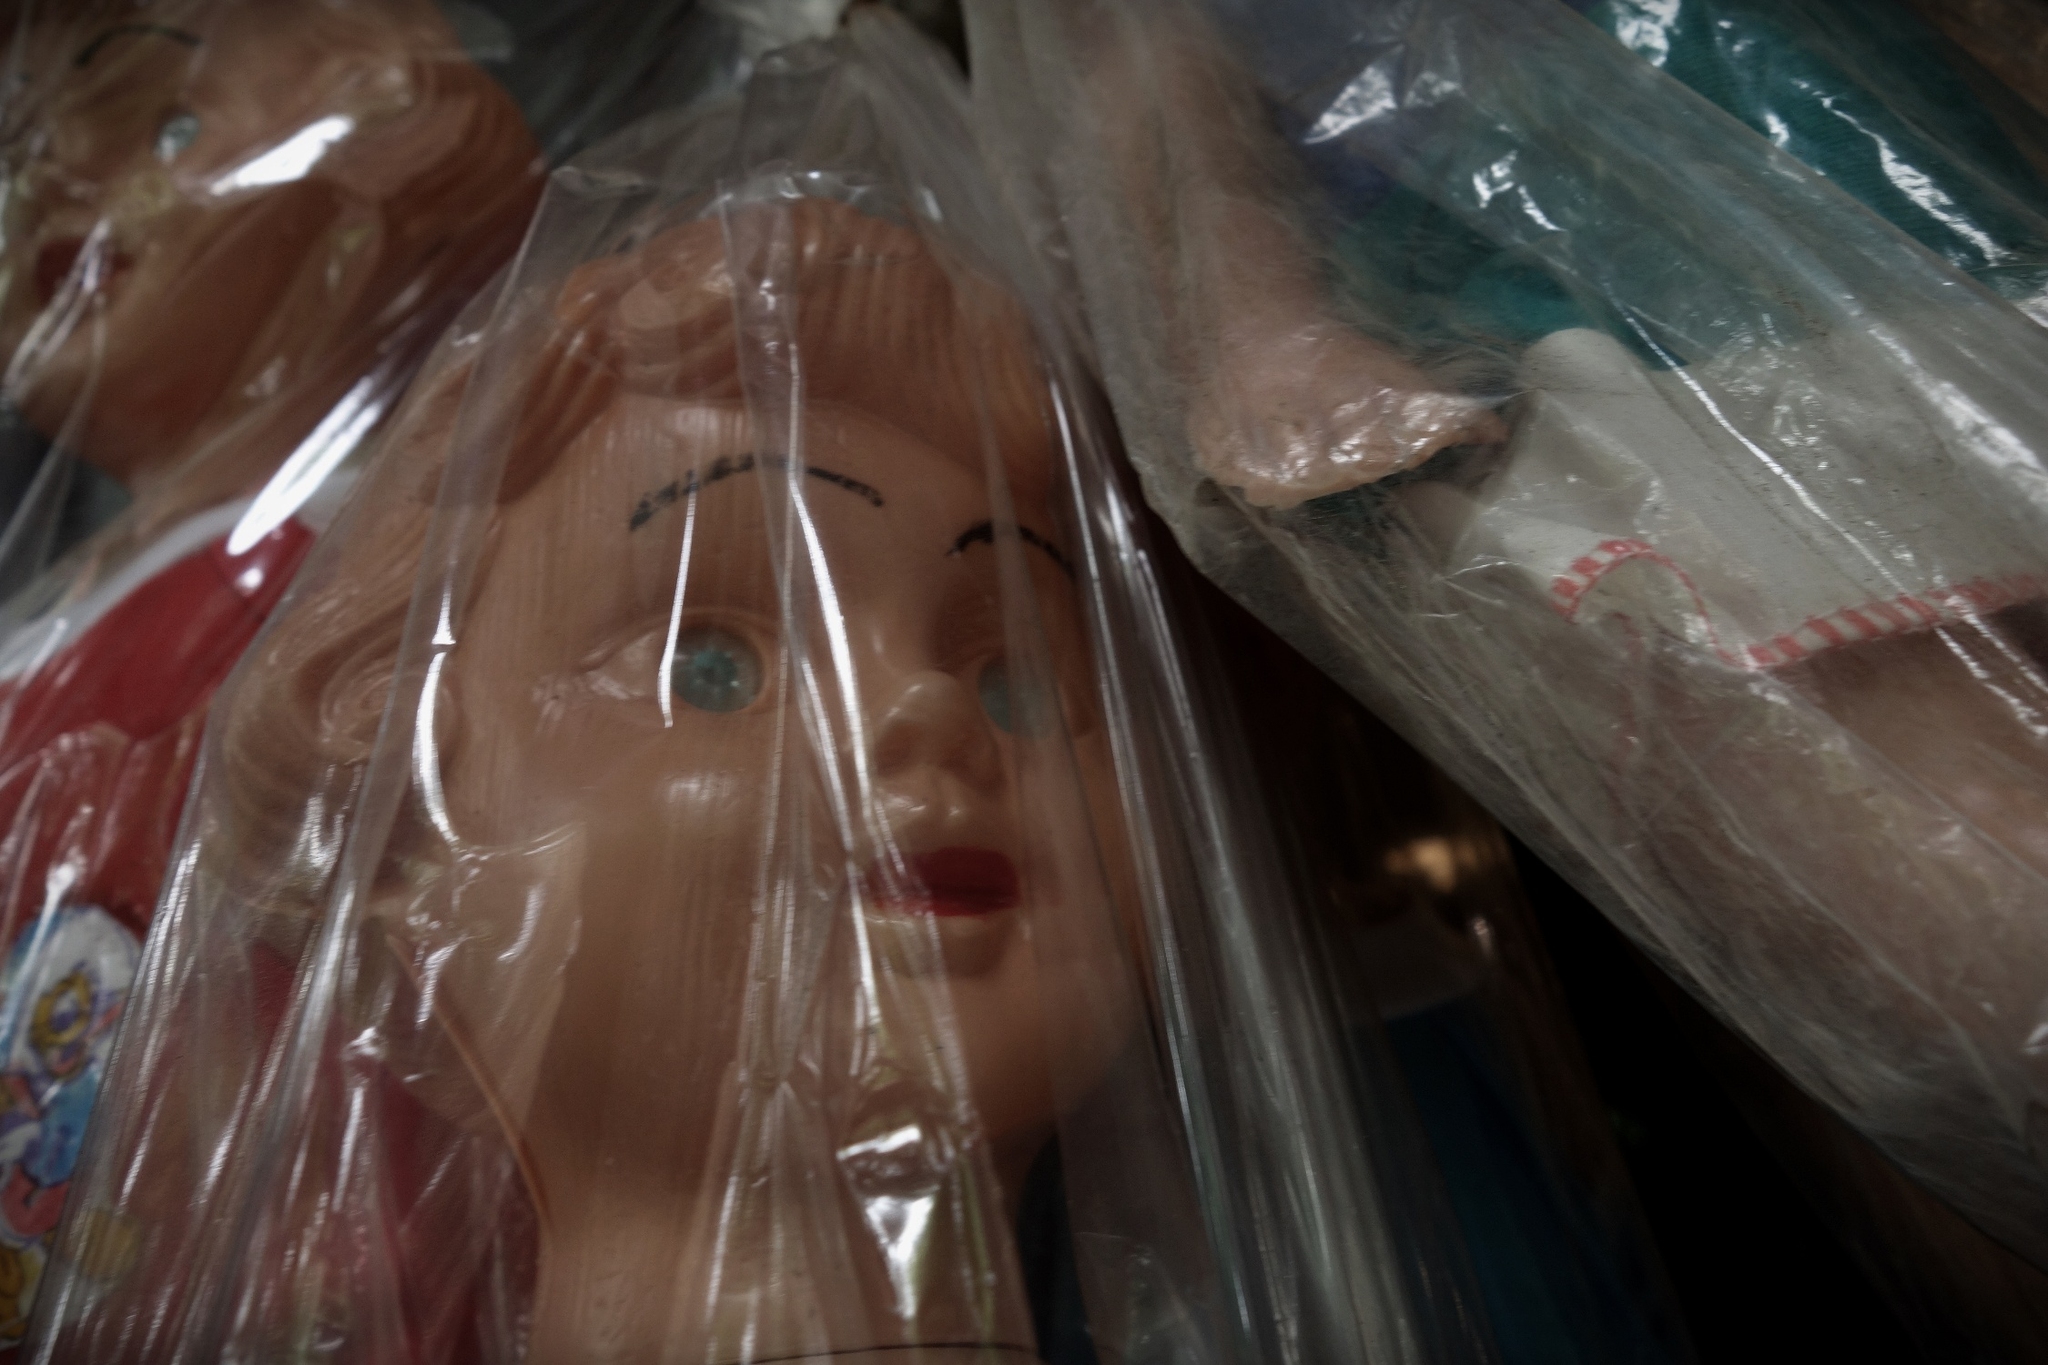Can you give a short and concise summary of the image? A close-up view of a doll's face in a plastic bag, with more dolls similarly wrapped in the background, indicating a carefully preserved collection. 